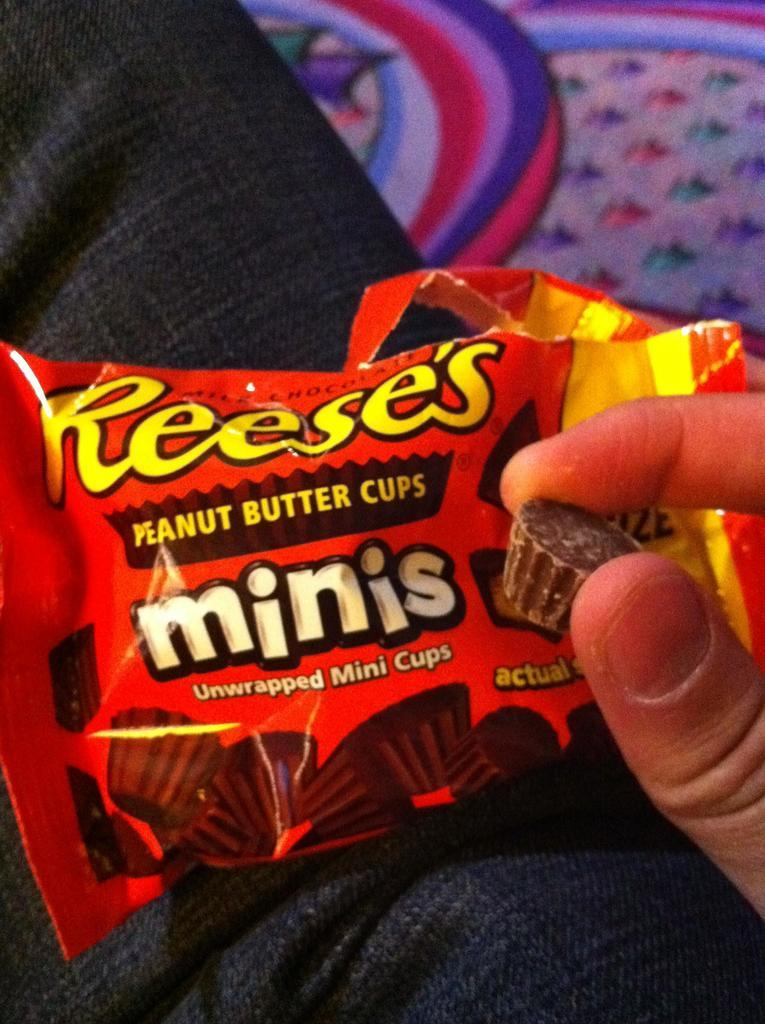What is present in the image? There is a person in the image. What is the person holding? The person is holding a chocolate. What else can be seen related to the chocolate? There is a chocolate wrap in the image. What type of tin can be seen in the image? There is no tin present in the image. Is the person in the image taking a flight? The image does not provide any information about the person taking a flight. 